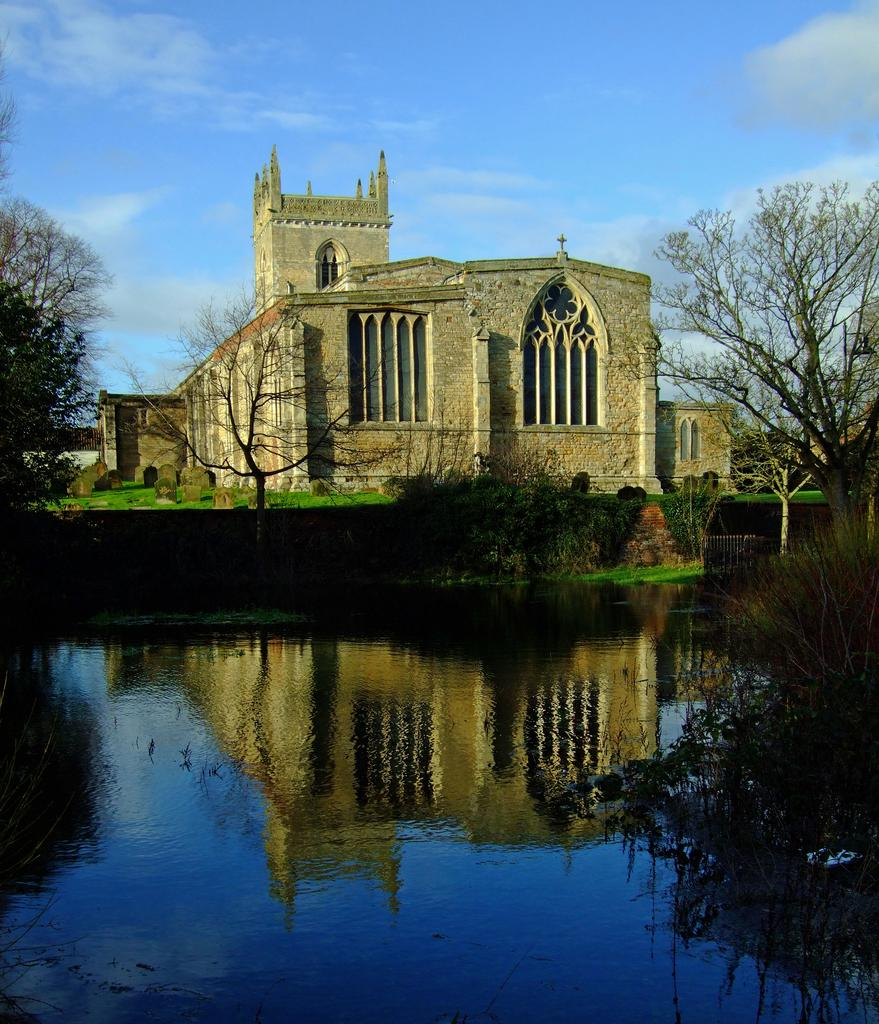What type of structure can be seen in the image? There is a building in the image. What other natural elements are present in the image? There are trees and water visible in the image. How would you describe the weather in the image? The sky is cloudy in the image. What type of verse can be seen written on the building in the image? There is no verse visible on the building in the image. What type of sail is attached to the trees in the image? There are no sails present in the image, as it features a building, trees, and water. 